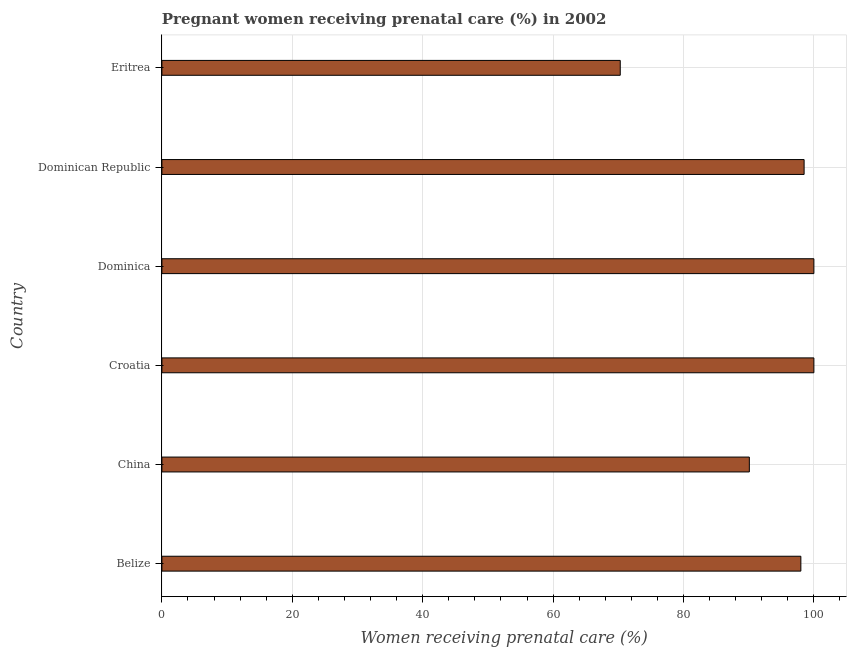Does the graph contain any zero values?
Offer a terse response. No. What is the title of the graph?
Make the answer very short. Pregnant women receiving prenatal care (%) in 2002. What is the label or title of the X-axis?
Offer a very short reply. Women receiving prenatal care (%). Across all countries, what is the minimum percentage of pregnant women receiving prenatal care?
Keep it short and to the point. 70.3. In which country was the percentage of pregnant women receiving prenatal care maximum?
Offer a very short reply. Croatia. In which country was the percentage of pregnant women receiving prenatal care minimum?
Ensure brevity in your answer.  Eritrea. What is the sum of the percentage of pregnant women receiving prenatal care?
Your response must be concise. 556.9. What is the difference between the percentage of pregnant women receiving prenatal care in China and Croatia?
Make the answer very short. -9.9. What is the average percentage of pregnant women receiving prenatal care per country?
Offer a very short reply. 92.82. What is the median percentage of pregnant women receiving prenatal care?
Make the answer very short. 98.25. What is the ratio of the percentage of pregnant women receiving prenatal care in China to that in Eritrea?
Your answer should be very brief. 1.28. Is the percentage of pregnant women receiving prenatal care in Belize less than that in China?
Your answer should be very brief. No. Is the difference between the percentage of pregnant women receiving prenatal care in Belize and China greater than the difference between any two countries?
Offer a terse response. No. What is the difference between the highest and the lowest percentage of pregnant women receiving prenatal care?
Your answer should be very brief. 29.7. In how many countries, is the percentage of pregnant women receiving prenatal care greater than the average percentage of pregnant women receiving prenatal care taken over all countries?
Offer a terse response. 4. How many bars are there?
Your answer should be compact. 6. How many countries are there in the graph?
Give a very brief answer. 6. What is the Women receiving prenatal care (%) of China?
Offer a terse response. 90.1. What is the Women receiving prenatal care (%) of Dominican Republic?
Keep it short and to the point. 98.5. What is the Women receiving prenatal care (%) of Eritrea?
Your answer should be very brief. 70.3. What is the difference between the Women receiving prenatal care (%) in Belize and Croatia?
Your answer should be very brief. -2. What is the difference between the Women receiving prenatal care (%) in Belize and Dominican Republic?
Ensure brevity in your answer.  -0.5. What is the difference between the Women receiving prenatal care (%) in Belize and Eritrea?
Offer a terse response. 27.7. What is the difference between the Women receiving prenatal care (%) in China and Croatia?
Make the answer very short. -9.9. What is the difference between the Women receiving prenatal care (%) in China and Dominica?
Provide a short and direct response. -9.9. What is the difference between the Women receiving prenatal care (%) in China and Eritrea?
Offer a terse response. 19.8. What is the difference between the Women receiving prenatal care (%) in Croatia and Eritrea?
Make the answer very short. 29.7. What is the difference between the Women receiving prenatal care (%) in Dominica and Dominican Republic?
Give a very brief answer. 1.5. What is the difference between the Women receiving prenatal care (%) in Dominica and Eritrea?
Provide a short and direct response. 29.7. What is the difference between the Women receiving prenatal care (%) in Dominican Republic and Eritrea?
Give a very brief answer. 28.2. What is the ratio of the Women receiving prenatal care (%) in Belize to that in China?
Give a very brief answer. 1.09. What is the ratio of the Women receiving prenatal care (%) in Belize to that in Croatia?
Your response must be concise. 0.98. What is the ratio of the Women receiving prenatal care (%) in Belize to that in Dominica?
Make the answer very short. 0.98. What is the ratio of the Women receiving prenatal care (%) in Belize to that in Dominican Republic?
Keep it short and to the point. 0.99. What is the ratio of the Women receiving prenatal care (%) in Belize to that in Eritrea?
Keep it short and to the point. 1.39. What is the ratio of the Women receiving prenatal care (%) in China to that in Croatia?
Make the answer very short. 0.9. What is the ratio of the Women receiving prenatal care (%) in China to that in Dominica?
Make the answer very short. 0.9. What is the ratio of the Women receiving prenatal care (%) in China to that in Dominican Republic?
Provide a short and direct response. 0.92. What is the ratio of the Women receiving prenatal care (%) in China to that in Eritrea?
Offer a very short reply. 1.28. What is the ratio of the Women receiving prenatal care (%) in Croatia to that in Eritrea?
Make the answer very short. 1.42. What is the ratio of the Women receiving prenatal care (%) in Dominica to that in Dominican Republic?
Your answer should be compact. 1.01. What is the ratio of the Women receiving prenatal care (%) in Dominica to that in Eritrea?
Ensure brevity in your answer.  1.42. What is the ratio of the Women receiving prenatal care (%) in Dominican Republic to that in Eritrea?
Keep it short and to the point. 1.4. 